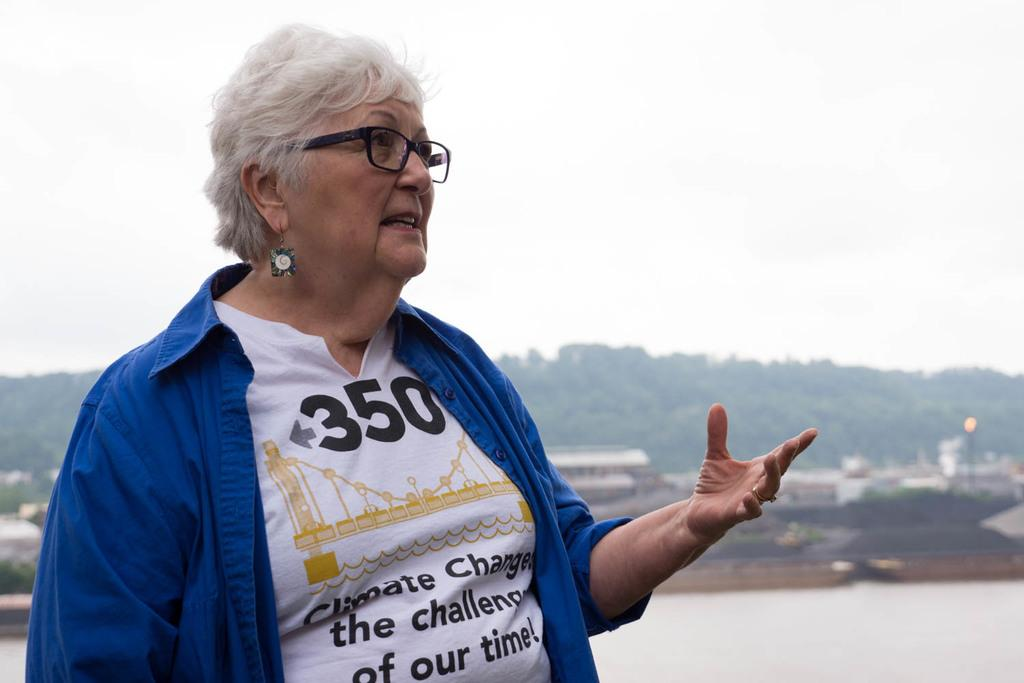Who is the main subject in the image? There is an old woman in the image. What is the old woman wearing? The old woman is wearing a white t-shirt and a blue shirt. What is the old woman doing in the image? The old woman is talking to someone. What can be seen in the background of the image? There is a small river and trees visible in the background of the image. What is the temperature setting on the oven in the image? There is no oven present in the image. How many people does the old woman love in the image? The image does not provide information about the old woman's feelings or relationships. 